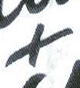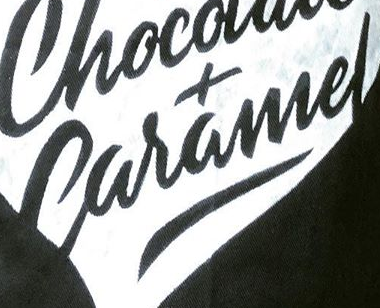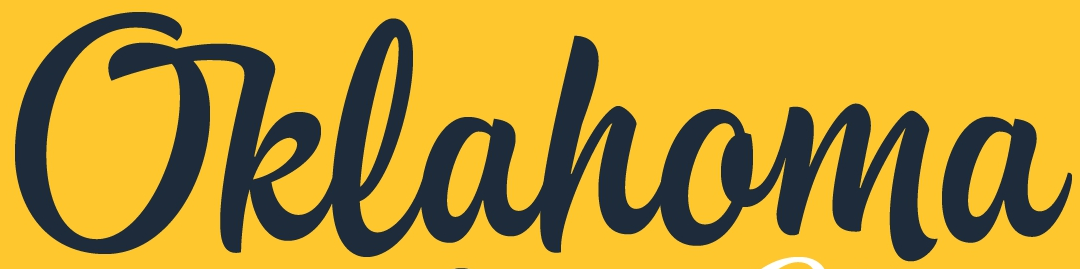What words are shown in these images in order, separated by a semicolon? +; Caramel; Oklahoma 